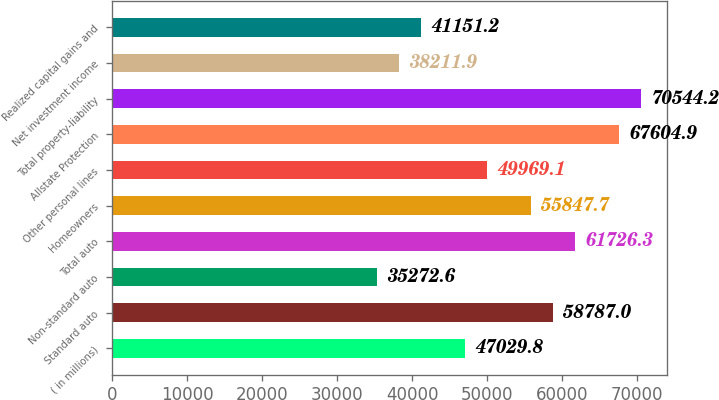Convert chart. <chart><loc_0><loc_0><loc_500><loc_500><bar_chart><fcel>( in millions)<fcel>Standard auto<fcel>Non-standard auto<fcel>Total auto<fcel>Homeowners<fcel>Other personal lines<fcel>Allstate Protection<fcel>Total property-liability<fcel>Net investment income<fcel>Realized capital gains and<nl><fcel>47029.8<fcel>58787<fcel>35272.6<fcel>61726.3<fcel>55847.7<fcel>49969.1<fcel>67604.9<fcel>70544.2<fcel>38211.9<fcel>41151.2<nl></chart> 